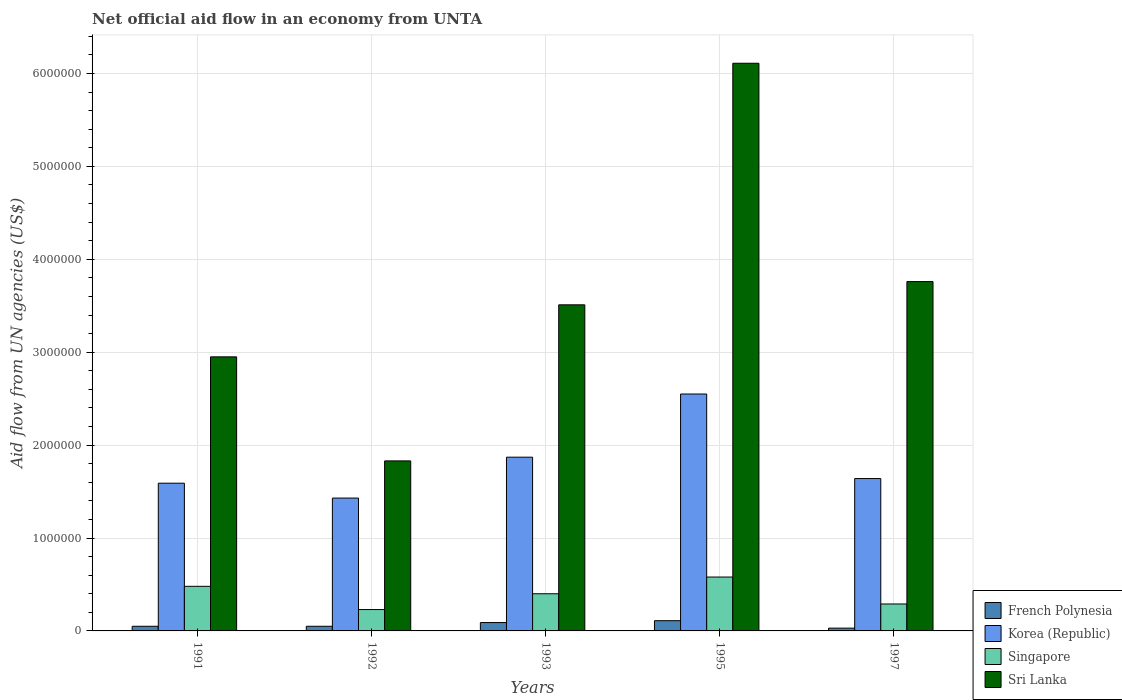How many groups of bars are there?
Provide a short and direct response. 5. Are the number of bars per tick equal to the number of legend labels?
Your answer should be very brief. Yes. What is the label of the 1st group of bars from the left?
Provide a short and direct response. 1991. Across all years, what is the maximum net official aid flow in Korea (Republic)?
Your answer should be compact. 2.55e+06. In which year was the net official aid flow in French Polynesia maximum?
Keep it short and to the point. 1995. What is the total net official aid flow in Sri Lanka in the graph?
Provide a short and direct response. 1.82e+07. What is the difference between the net official aid flow in Korea (Republic) in 1997 and the net official aid flow in French Polynesia in 1995?
Keep it short and to the point. 1.53e+06. What is the average net official aid flow in Sri Lanka per year?
Keep it short and to the point. 3.63e+06. In the year 1993, what is the difference between the net official aid flow in French Polynesia and net official aid flow in Sri Lanka?
Provide a short and direct response. -3.42e+06. In how many years, is the net official aid flow in French Polynesia greater than 2800000 US$?
Your answer should be very brief. 0. What is the ratio of the net official aid flow in Singapore in 1991 to that in 1997?
Ensure brevity in your answer.  1.66. In how many years, is the net official aid flow in Sri Lanka greater than the average net official aid flow in Sri Lanka taken over all years?
Ensure brevity in your answer.  2. Is the sum of the net official aid flow in Singapore in 1991 and 1992 greater than the maximum net official aid flow in French Polynesia across all years?
Offer a very short reply. Yes. Is it the case that in every year, the sum of the net official aid flow in Korea (Republic) and net official aid flow in French Polynesia is greater than the sum of net official aid flow in Singapore and net official aid flow in Sri Lanka?
Keep it short and to the point. No. What does the 4th bar from the left in 1992 represents?
Offer a very short reply. Sri Lanka. What does the 4th bar from the right in 1991 represents?
Keep it short and to the point. French Polynesia. How many bars are there?
Provide a short and direct response. 20. Are all the bars in the graph horizontal?
Provide a succinct answer. No. Are the values on the major ticks of Y-axis written in scientific E-notation?
Offer a terse response. No. How many legend labels are there?
Your response must be concise. 4. How are the legend labels stacked?
Your answer should be compact. Vertical. What is the title of the graph?
Offer a very short reply. Net official aid flow in an economy from UNTA. What is the label or title of the X-axis?
Provide a succinct answer. Years. What is the label or title of the Y-axis?
Give a very brief answer. Aid flow from UN agencies (US$). What is the Aid flow from UN agencies (US$) in French Polynesia in 1991?
Your response must be concise. 5.00e+04. What is the Aid flow from UN agencies (US$) in Korea (Republic) in 1991?
Your answer should be compact. 1.59e+06. What is the Aid flow from UN agencies (US$) of Sri Lanka in 1991?
Provide a short and direct response. 2.95e+06. What is the Aid flow from UN agencies (US$) of Korea (Republic) in 1992?
Make the answer very short. 1.43e+06. What is the Aid flow from UN agencies (US$) in Sri Lanka in 1992?
Your response must be concise. 1.83e+06. What is the Aid flow from UN agencies (US$) in French Polynesia in 1993?
Make the answer very short. 9.00e+04. What is the Aid flow from UN agencies (US$) in Korea (Republic) in 1993?
Offer a terse response. 1.87e+06. What is the Aid flow from UN agencies (US$) in Sri Lanka in 1993?
Make the answer very short. 3.51e+06. What is the Aid flow from UN agencies (US$) in Korea (Republic) in 1995?
Provide a succinct answer. 2.55e+06. What is the Aid flow from UN agencies (US$) in Singapore in 1995?
Your answer should be compact. 5.80e+05. What is the Aid flow from UN agencies (US$) of Sri Lanka in 1995?
Make the answer very short. 6.11e+06. What is the Aid flow from UN agencies (US$) of Korea (Republic) in 1997?
Provide a succinct answer. 1.64e+06. What is the Aid flow from UN agencies (US$) of Singapore in 1997?
Your response must be concise. 2.90e+05. What is the Aid flow from UN agencies (US$) in Sri Lanka in 1997?
Keep it short and to the point. 3.76e+06. Across all years, what is the maximum Aid flow from UN agencies (US$) of Korea (Republic)?
Your answer should be compact. 2.55e+06. Across all years, what is the maximum Aid flow from UN agencies (US$) of Singapore?
Ensure brevity in your answer.  5.80e+05. Across all years, what is the maximum Aid flow from UN agencies (US$) of Sri Lanka?
Your response must be concise. 6.11e+06. Across all years, what is the minimum Aid flow from UN agencies (US$) of Korea (Republic)?
Offer a very short reply. 1.43e+06. Across all years, what is the minimum Aid flow from UN agencies (US$) in Singapore?
Your response must be concise. 2.30e+05. Across all years, what is the minimum Aid flow from UN agencies (US$) of Sri Lanka?
Give a very brief answer. 1.83e+06. What is the total Aid flow from UN agencies (US$) of Korea (Republic) in the graph?
Provide a short and direct response. 9.08e+06. What is the total Aid flow from UN agencies (US$) in Singapore in the graph?
Provide a short and direct response. 1.98e+06. What is the total Aid flow from UN agencies (US$) of Sri Lanka in the graph?
Ensure brevity in your answer.  1.82e+07. What is the difference between the Aid flow from UN agencies (US$) of Sri Lanka in 1991 and that in 1992?
Your answer should be very brief. 1.12e+06. What is the difference between the Aid flow from UN agencies (US$) in French Polynesia in 1991 and that in 1993?
Your response must be concise. -4.00e+04. What is the difference between the Aid flow from UN agencies (US$) in Korea (Republic) in 1991 and that in 1993?
Your answer should be compact. -2.80e+05. What is the difference between the Aid flow from UN agencies (US$) of Sri Lanka in 1991 and that in 1993?
Your answer should be compact. -5.60e+05. What is the difference between the Aid flow from UN agencies (US$) of French Polynesia in 1991 and that in 1995?
Give a very brief answer. -6.00e+04. What is the difference between the Aid flow from UN agencies (US$) of Korea (Republic) in 1991 and that in 1995?
Make the answer very short. -9.60e+05. What is the difference between the Aid flow from UN agencies (US$) in Sri Lanka in 1991 and that in 1995?
Your answer should be compact. -3.16e+06. What is the difference between the Aid flow from UN agencies (US$) of French Polynesia in 1991 and that in 1997?
Your answer should be compact. 2.00e+04. What is the difference between the Aid flow from UN agencies (US$) of Korea (Republic) in 1991 and that in 1997?
Your answer should be very brief. -5.00e+04. What is the difference between the Aid flow from UN agencies (US$) in Singapore in 1991 and that in 1997?
Keep it short and to the point. 1.90e+05. What is the difference between the Aid flow from UN agencies (US$) of Sri Lanka in 1991 and that in 1997?
Provide a succinct answer. -8.10e+05. What is the difference between the Aid flow from UN agencies (US$) in Korea (Republic) in 1992 and that in 1993?
Keep it short and to the point. -4.40e+05. What is the difference between the Aid flow from UN agencies (US$) in Singapore in 1992 and that in 1993?
Your answer should be compact. -1.70e+05. What is the difference between the Aid flow from UN agencies (US$) in Sri Lanka in 1992 and that in 1993?
Ensure brevity in your answer.  -1.68e+06. What is the difference between the Aid flow from UN agencies (US$) of Korea (Republic) in 1992 and that in 1995?
Provide a short and direct response. -1.12e+06. What is the difference between the Aid flow from UN agencies (US$) in Singapore in 1992 and that in 1995?
Your response must be concise. -3.50e+05. What is the difference between the Aid flow from UN agencies (US$) of Sri Lanka in 1992 and that in 1995?
Your answer should be compact. -4.28e+06. What is the difference between the Aid flow from UN agencies (US$) of Korea (Republic) in 1992 and that in 1997?
Offer a very short reply. -2.10e+05. What is the difference between the Aid flow from UN agencies (US$) in Singapore in 1992 and that in 1997?
Your response must be concise. -6.00e+04. What is the difference between the Aid flow from UN agencies (US$) in Sri Lanka in 1992 and that in 1997?
Your answer should be compact. -1.93e+06. What is the difference between the Aid flow from UN agencies (US$) of French Polynesia in 1993 and that in 1995?
Your response must be concise. -2.00e+04. What is the difference between the Aid flow from UN agencies (US$) of Korea (Republic) in 1993 and that in 1995?
Give a very brief answer. -6.80e+05. What is the difference between the Aid flow from UN agencies (US$) in Sri Lanka in 1993 and that in 1995?
Offer a terse response. -2.60e+06. What is the difference between the Aid flow from UN agencies (US$) of French Polynesia in 1995 and that in 1997?
Offer a very short reply. 8.00e+04. What is the difference between the Aid flow from UN agencies (US$) of Korea (Republic) in 1995 and that in 1997?
Ensure brevity in your answer.  9.10e+05. What is the difference between the Aid flow from UN agencies (US$) of Sri Lanka in 1995 and that in 1997?
Make the answer very short. 2.35e+06. What is the difference between the Aid flow from UN agencies (US$) in French Polynesia in 1991 and the Aid flow from UN agencies (US$) in Korea (Republic) in 1992?
Provide a short and direct response. -1.38e+06. What is the difference between the Aid flow from UN agencies (US$) in French Polynesia in 1991 and the Aid flow from UN agencies (US$) in Sri Lanka in 1992?
Give a very brief answer. -1.78e+06. What is the difference between the Aid flow from UN agencies (US$) in Korea (Republic) in 1991 and the Aid flow from UN agencies (US$) in Singapore in 1992?
Your answer should be compact. 1.36e+06. What is the difference between the Aid flow from UN agencies (US$) in Korea (Republic) in 1991 and the Aid flow from UN agencies (US$) in Sri Lanka in 1992?
Provide a short and direct response. -2.40e+05. What is the difference between the Aid flow from UN agencies (US$) in Singapore in 1991 and the Aid flow from UN agencies (US$) in Sri Lanka in 1992?
Give a very brief answer. -1.35e+06. What is the difference between the Aid flow from UN agencies (US$) of French Polynesia in 1991 and the Aid flow from UN agencies (US$) of Korea (Republic) in 1993?
Make the answer very short. -1.82e+06. What is the difference between the Aid flow from UN agencies (US$) of French Polynesia in 1991 and the Aid flow from UN agencies (US$) of Singapore in 1993?
Ensure brevity in your answer.  -3.50e+05. What is the difference between the Aid flow from UN agencies (US$) in French Polynesia in 1991 and the Aid flow from UN agencies (US$) in Sri Lanka in 1993?
Make the answer very short. -3.46e+06. What is the difference between the Aid flow from UN agencies (US$) in Korea (Republic) in 1991 and the Aid flow from UN agencies (US$) in Singapore in 1993?
Provide a short and direct response. 1.19e+06. What is the difference between the Aid flow from UN agencies (US$) in Korea (Republic) in 1991 and the Aid flow from UN agencies (US$) in Sri Lanka in 1993?
Your answer should be very brief. -1.92e+06. What is the difference between the Aid flow from UN agencies (US$) of Singapore in 1991 and the Aid flow from UN agencies (US$) of Sri Lanka in 1993?
Provide a succinct answer. -3.03e+06. What is the difference between the Aid flow from UN agencies (US$) of French Polynesia in 1991 and the Aid flow from UN agencies (US$) of Korea (Republic) in 1995?
Give a very brief answer. -2.50e+06. What is the difference between the Aid flow from UN agencies (US$) in French Polynesia in 1991 and the Aid flow from UN agencies (US$) in Singapore in 1995?
Provide a succinct answer. -5.30e+05. What is the difference between the Aid flow from UN agencies (US$) in French Polynesia in 1991 and the Aid flow from UN agencies (US$) in Sri Lanka in 1995?
Ensure brevity in your answer.  -6.06e+06. What is the difference between the Aid flow from UN agencies (US$) in Korea (Republic) in 1991 and the Aid flow from UN agencies (US$) in Singapore in 1995?
Your answer should be compact. 1.01e+06. What is the difference between the Aid flow from UN agencies (US$) of Korea (Republic) in 1991 and the Aid flow from UN agencies (US$) of Sri Lanka in 1995?
Your response must be concise. -4.52e+06. What is the difference between the Aid flow from UN agencies (US$) of Singapore in 1991 and the Aid flow from UN agencies (US$) of Sri Lanka in 1995?
Keep it short and to the point. -5.63e+06. What is the difference between the Aid flow from UN agencies (US$) of French Polynesia in 1991 and the Aid flow from UN agencies (US$) of Korea (Republic) in 1997?
Your answer should be compact. -1.59e+06. What is the difference between the Aid flow from UN agencies (US$) in French Polynesia in 1991 and the Aid flow from UN agencies (US$) in Singapore in 1997?
Offer a terse response. -2.40e+05. What is the difference between the Aid flow from UN agencies (US$) in French Polynesia in 1991 and the Aid flow from UN agencies (US$) in Sri Lanka in 1997?
Your answer should be compact. -3.71e+06. What is the difference between the Aid flow from UN agencies (US$) of Korea (Republic) in 1991 and the Aid flow from UN agencies (US$) of Singapore in 1997?
Ensure brevity in your answer.  1.30e+06. What is the difference between the Aid flow from UN agencies (US$) in Korea (Republic) in 1991 and the Aid flow from UN agencies (US$) in Sri Lanka in 1997?
Offer a very short reply. -2.17e+06. What is the difference between the Aid flow from UN agencies (US$) of Singapore in 1991 and the Aid flow from UN agencies (US$) of Sri Lanka in 1997?
Your answer should be compact. -3.28e+06. What is the difference between the Aid flow from UN agencies (US$) of French Polynesia in 1992 and the Aid flow from UN agencies (US$) of Korea (Republic) in 1993?
Provide a short and direct response. -1.82e+06. What is the difference between the Aid flow from UN agencies (US$) in French Polynesia in 1992 and the Aid flow from UN agencies (US$) in Singapore in 1993?
Keep it short and to the point. -3.50e+05. What is the difference between the Aid flow from UN agencies (US$) in French Polynesia in 1992 and the Aid flow from UN agencies (US$) in Sri Lanka in 1993?
Your response must be concise. -3.46e+06. What is the difference between the Aid flow from UN agencies (US$) in Korea (Republic) in 1992 and the Aid flow from UN agencies (US$) in Singapore in 1993?
Offer a very short reply. 1.03e+06. What is the difference between the Aid flow from UN agencies (US$) in Korea (Republic) in 1992 and the Aid flow from UN agencies (US$) in Sri Lanka in 1993?
Offer a very short reply. -2.08e+06. What is the difference between the Aid flow from UN agencies (US$) of Singapore in 1992 and the Aid flow from UN agencies (US$) of Sri Lanka in 1993?
Ensure brevity in your answer.  -3.28e+06. What is the difference between the Aid flow from UN agencies (US$) in French Polynesia in 1992 and the Aid flow from UN agencies (US$) in Korea (Republic) in 1995?
Your answer should be very brief. -2.50e+06. What is the difference between the Aid flow from UN agencies (US$) in French Polynesia in 1992 and the Aid flow from UN agencies (US$) in Singapore in 1995?
Offer a very short reply. -5.30e+05. What is the difference between the Aid flow from UN agencies (US$) in French Polynesia in 1992 and the Aid flow from UN agencies (US$) in Sri Lanka in 1995?
Your answer should be compact. -6.06e+06. What is the difference between the Aid flow from UN agencies (US$) in Korea (Republic) in 1992 and the Aid flow from UN agencies (US$) in Singapore in 1995?
Offer a terse response. 8.50e+05. What is the difference between the Aid flow from UN agencies (US$) of Korea (Republic) in 1992 and the Aid flow from UN agencies (US$) of Sri Lanka in 1995?
Make the answer very short. -4.68e+06. What is the difference between the Aid flow from UN agencies (US$) in Singapore in 1992 and the Aid flow from UN agencies (US$) in Sri Lanka in 1995?
Your answer should be very brief. -5.88e+06. What is the difference between the Aid flow from UN agencies (US$) in French Polynesia in 1992 and the Aid flow from UN agencies (US$) in Korea (Republic) in 1997?
Offer a terse response. -1.59e+06. What is the difference between the Aid flow from UN agencies (US$) in French Polynesia in 1992 and the Aid flow from UN agencies (US$) in Sri Lanka in 1997?
Ensure brevity in your answer.  -3.71e+06. What is the difference between the Aid flow from UN agencies (US$) in Korea (Republic) in 1992 and the Aid flow from UN agencies (US$) in Singapore in 1997?
Keep it short and to the point. 1.14e+06. What is the difference between the Aid flow from UN agencies (US$) in Korea (Republic) in 1992 and the Aid flow from UN agencies (US$) in Sri Lanka in 1997?
Provide a short and direct response. -2.33e+06. What is the difference between the Aid flow from UN agencies (US$) of Singapore in 1992 and the Aid flow from UN agencies (US$) of Sri Lanka in 1997?
Make the answer very short. -3.53e+06. What is the difference between the Aid flow from UN agencies (US$) in French Polynesia in 1993 and the Aid flow from UN agencies (US$) in Korea (Republic) in 1995?
Your answer should be very brief. -2.46e+06. What is the difference between the Aid flow from UN agencies (US$) in French Polynesia in 1993 and the Aid flow from UN agencies (US$) in Singapore in 1995?
Give a very brief answer. -4.90e+05. What is the difference between the Aid flow from UN agencies (US$) in French Polynesia in 1993 and the Aid flow from UN agencies (US$) in Sri Lanka in 1995?
Ensure brevity in your answer.  -6.02e+06. What is the difference between the Aid flow from UN agencies (US$) in Korea (Republic) in 1993 and the Aid flow from UN agencies (US$) in Singapore in 1995?
Provide a succinct answer. 1.29e+06. What is the difference between the Aid flow from UN agencies (US$) in Korea (Republic) in 1993 and the Aid flow from UN agencies (US$) in Sri Lanka in 1995?
Make the answer very short. -4.24e+06. What is the difference between the Aid flow from UN agencies (US$) in Singapore in 1993 and the Aid flow from UN agencies (US$) in Sri Lanka in 1995?
Offer a very short reply. -5.71e+06. What is the difference between the Aid flow from UN agencies (US$) in French Polynesia in 1993 and the Aid flow from UN agencies (US$) in Korea (Republic) in 1997?
Give a very brief answer. -1.55e+06. What is the difference between the Aid flow from UN agencies (US$) of French Polynesia in 1993 and the Aid flow from UN agencies (US$) of Singapore in 1997?
Give a very brief answer. -2.00e+05. What is the difference between the Aid flow from UN agencies (US$) in French Polynesia in 1993 and the Aid flow from UN agencies (US$) in Sri Lanka in 1997?
Provide a short and direct response. -3.67e+06. What is the difference between the Aid flow from UN agencies (US$) in Korea (Republic) in 1993 and the Aid flow from UN agencies (US$) in Singapore in 1997?
Your answer should be very brief. 1.58e+06. What is the difference between the Aid flow from UN agencies (US$) in Korea (Republic) in 1993 and the Aid flow from UN agencies (US$) in Sri Lanka in 1997?
Give a very brief answer. -1.89e+06. What is the difference between the Aid flow from UN agencies (US$) of Singapore in 1993 and the Aid flow from UN agencies (US$) of Sri Lanka in 1997?
Provide a short and direct response. -3.36e+06. What is the difference between the Aid flow from UN agencies (US$) of French Polynesia in 1995 and the Aid flow from UN agencies (US$) of Korea (Republic) in 1997?
Provide a short and direct response. -1.53e+06. What is the difference between the Aid flow from UN agencies (US$) of French Polynesia in 1995 and the Aid flow from UN agencies (US$) of Sri Lanka in 1997?
Offer a terse response. -3.65e+06. What is the difference between the Aid flow from UN agencies (US$) of Korea (Republic) in 1995 and the Aid flow from UN agencies (US$) of Singapore in 1997?
Give a very brief answer. 2.26e+06. What is the difference between the Aid flow from UN agencies (US$) of Korea (Republic) in 1995 and the Aid flow from UN agencies (US$) of Sri Lanka in 1997?
Ensure brevity in your answer.  -1.21e+06. What is the difference between the Aid flow from UN agencies (US$) of Singapore in 1995 and the Aid flow from UN agencies (US$) of Sri Lanka in 1997?
Offer a very short reply. -3.18e+06. What is the average Aid flow from UN agencies (US$) of French Polynesia per year?
Make the answer very short. 6.60e+04. What is the average Aid flow from UN agencies (US$) in Korea (Republic) per year?
Provide a succinct answer. 1.82e+06. What is the average Aid flow from UN agencies (US$) in Singapore per year?
Your response must be concise. 3.96e+05. What is the average Aid flow from UN agencies (US$) of Sri Lanka per year?
Provide a succinct answer. 3.63e+06. In the year 1991, what is the difference between the Aid flow from UN agencies (US$) in French Polynesia and Aid flow from UN agencies (US$) in Korea (Republic)?
Make the answer very short. -1.54e+06. In the year 1991, what is the difference between the Aid flow from UN agencies (US$) of French Polynesia and Aid flow from UN agencies (US$) of Singapore?
Your response must be concise. -4.30e+05. In the year 1991, what is the difference between the Aid flow from UN agencies (US$) in French Polynesia and Aid flow from UN agencies (US$) in Sri Lanka?
Ensure brevity in your answer.  -2.90e+06. In the year 1991, what is the difference between the Aid flow from UN agencies (US$) in Korea (Republic) and Aid flow from UN agencies (US$) in Singapore?
Offer a very short reply. 1.11e+06. In the year 1991, what is the difference between the Aid flow from UN agencies (US$) of Korea (Republic) and Aid flow from UN agencies (US$) of Sri Lanka?
Your answer should be compact. -1.36e+06. In the year 1991, what is the difference between the Aid flow from UN agencies (US$) of Singapore and Aid flow from UN agencies (US$) of Sri Lanka?
Give a very brief answer. -2.47e+06. In the year 1992, what is the difference between the Aid flow from UN agencies (US$) of French Polynesia and Aid flow from UN agencies (US$) of Korea (Republic)?
Your response must be concise. -1.38e+06. In the year 1992, what is the difference between the Aid flow from UN agencies (US$) in French Polynesia and Aid flow from UN agencies (US$) in Singapore?
Provide a succinct answer. -1.80e+05. In the year 1992, what is the difference between the Aid flow from UN agencies (US$) in French Polynesia and Aid flow from UN agencies (US$) in Sri Lanka?
Provide a short and direct response. -1.78e+06. In the year 1992, what is the difference between the Aid flow from UN agencies (US$) of Korea (Republic) and Aid flow from UN agencies (US$) of Singapore?
Offer a very short reply. 1.20e+06. In the year 1992, what is the difference between the Aid flow from UN agencies (US$) of Korea (Republic) and Aid flow from UN agencies (US$) of Sri Lanka?
Ensure brevity in your answer.  -4.00e+05. In the year 1992, what is the difference between the Aid flow from UN agencies (US$) of Singapore and Aid flow from UN agencies (US$) of Sri Lanka?
Give a very brief answer. -1.60e+06. In the year 1993, what is the difference between the Aid flow from UN agencies (US$) of French Polynesia and Aid flow from UN agencies (US$) of Korea (Republic)?
Make the answer very short. -1.78e+06. In the year 1993, what is the difference between the Aid flow from UN agencies (US$) in French Polynesia and Aid flow from UN agencies (US$) in Singapore?
Provide a short and direct response. -3.10e+05. In the year 1993, what is the difference between the Aid flow from UN agencies (US$) in French Polynesia and Aid flow from UN agencies (US$) in Sri Lanka?
Your answer should be compact. -3.42e+06. In the year 1993, what is the difference between the Aid flow from UN agencies (US$) in Korea (Republic) and Aid flow from UN agencies (US$) in Singapore?
Provide a succinct answer. 1.47e+06. In the year 1993, what is the difference between the Aid flow from UN agencies (US$) in Korea (Republic) and Aid flow from UN agencies (US$) in Sri Lanka?
Keep it short and to the point. -1.64e+06. In the year 1993, what is the difference between the Aid flow from UN agencies (US$) in Singapore and Aid flow from UN agencies (US$) in Sri Lanka?
Give a very brief answer. -3.11e+06. In the year 1995, what is the difference between the Aid flow from UN agencies (US$) of French Polynesia and Aid flow from UN agencies (US$) of Korea (Republic)?
Ensure brevity in your answer.  -2.44e+06. In the year 1995, what is the difference between the Aid flow from UN agencies (US$) in French Polynesia and Aid flow from UN agencies (US$) in Singapore?
Your response must be concise. -4.70e+05. In the year 1995, what is the difference between the Aid flow from UN agencies (US$) in French Polynesia and Aid flow from UN agencies (US$) in Sri Lanka?
Ensure brevity in your answer.  -6.00e+06. In the year 1995, what is the difference between the Aid flow from UN agencies (US$) in Korea (Republic) and Aid flow from UN agencies (US$) in Singapore?
Your answer should be very brief. 1.97e+06. In the year 1995, what is the difference between the Aid flow from UN agencies (US$) in Korea (Republic) and Aid flow from UN agencies (US$) in Sri Lanka?
Keep it short and to the point. -3.56e+06. In the year 1995, what is the difference between the Aid flow from UN agencies (US$) in Singapore and Aid flow from UN agencies (US$) in Sri Lanka?
Make the answer very short. -5.53e+06. In the year 1997, what is the difference between the Aid flow from UN agencies (US$) in French Polynesia and Aid flow from UN agencies (US$) in Korea (Republic)?
Your response must be concise. -1.61e+06. In the year 1997, what is the difference between the Aid flow from UN agencies (US$) in French Polynesia and Aid flow from UN agencies (US$) in Sri Lanka?
Your answer should be very brief. -3.73e+06. In the year 1997, what is the difference between the Aid flow from UN agencies (US$) of Korea (Republic) and Aid flow from UN agencies (US$) of Singapore?
Your answer should be compact. 1.35e+06. In the year 1997, what is the difference between the Aid flow from UN agencies (US$) in Korea (Republic) and Aid flow from UN agencies (US$) in Sri Lanka?
Offer a very short reply. -2.12e+06. In the year 1997, what is the difference between the Aid flow from UN agencies (US$) in Singapore and Aid flow from UN agencies (US$) in Sri Lanka?
Give a very brief answer. -3.47e+06. What is the ratio of the Aid flow from UN agencies (US$) of French Polynesia in 1991 to that in 1992?
Make the answer very short. 1. What is the ratio of the Aid flow from UN agencies (US$) in Korea (Republic) in 1991 to that in 1992?
Ensure brevity in your answer.  1.11. What is the ratio of the Aid flow from UN agencies (US$) of Singapore in 1991 to that in 1992?
Give a very brief answer. 2.09. What is the ratio of the Aid flow from UN agencies (US$) in Sri Lanka in 1991 to that in 1992?
Offer a terse response. 1.61. What is the ratio of the Aid flow from UN agencies (US$) of French Polynesia in 1991 to that in 1993?
Make the answer very short. 0.56. What is the ratio of the Aid flow from UN agencies (US$) of Korea (Republic) in 1991 to that in 1993?
Your response must be concise. 0.85. What is the ratio of the Aid flow from UN agencies (US$) of Singapore in 1991 to that in 1993?
Ensure brevity in your answer.  1.2. What is the ratio of the Aid flow from UN agencies (US$) of Sri Lanka in 1991 to that in 1993?
Make the answer very short. 0.84. What is the ratio of the Aid flow from UN agencies (US$) in French Polynesia in 1991 to that in 1995?
Make the answer very short. 0.45. What is the ratio of the Aid flow from UN agencies (US$) of Korea (Republic) in 1991 to that in 1995?
Offer a terse response. 0.62. What is the ratio of the Aid flow from UN agencies (US$) of Singapore in 1991 to that in 1995?
Provide a short and direct response. 0.83. What is the ratio of the Aid flow from UN agencies (US$) in Sri Lanka in 1991 to that in 1995?
Offer a very short reply. 0.48. What is the ratio of the Aid flow from UN agencies (US$) of Korea (Republic) in 1991 to that in 1997?
Your answer should be very brief. 0.97. What is the ratio of the Aid flow from UN agencies (US$) of Singapore in 1991 to that in 1997?
Your response must be concise. 1.66. What is the ratio of the Aid flow from UN agencies (US$) in Sri Lanka in 1991 to that in 1997?
Your answer should be very brief. 0.78. What is the ratio of the Aid flow from UN agencies (US$) of French Polynesia in 1992 to that in 1993?
Provide a succinct answer. 0.56. What is the ratio of the Aid flow from UN agencies (US$) of Korea (Republic) in 1992 to that in 1993?
Ensure brevity in your answer.  0.76. What is the ratio of the Aid flow from UN agencies (US$) in Singapore in 1992 to that in 1993?
Provide a succinct answer. 0.57. What is the ratio of the Aid flow from UN agencies (US$) in Sri Lanka in 1992 to that in 1993?
Ensure brevity in your answer.  0.52. What is the ratio of the Aid flow from UN agencies (US$) in French Polynesia in 1992 to that in 1995?
Your answer should be very brief. 0.45. What is the ratio of the Aid flow from UN agencies (US$) of Korea (Republic) in 1992 to that in 1995?
Provide a succinct answer. 0.56. What is the ratio of the Aid flow from UN agencies (US$) in Singapore in 1992 to that in 1995?
Provide a succinct answer. 0.4. What is the ratio of the Aid flow from UN agencies (US$) of Sri Lanka in 1992 to that in 1995?
Provide a succinct answer. 0.3. What is the ratio of the Aid flow from UN agencies (US$) in Korea (Republic) in 1992 to that in 1997?
Offer a very short reply. 0.87. What is the ratio of the Aid flow from UN agencies (US$) of Singapore in 1992 to that in 1997?
Provide a succinct answer. 0.79. What is the ratio of the Aid flow from UN agencies (US$) in Sri Lanka in 1992 to that in 1997?
Keep it short and to the point. 0.49. What is the ratio of the Aid flow from UN agencies (US$) in French Polynesia in 1993 to that in 1995?
Your response must be concise. 0.82. What is the ratio of the Aid flow from UN agencies (US$) of Korea (Republic) in 1993 to that in 1995?
Ensure brevity in your answer.  0.73. What is the ratio of the Aid flow from UN agencies (US$) of Singapore in 1993 to that in 1995?
Offer a terse response. 0.69. What is the ratio of the Aid flow from UN agencies (US$) of Sri Lanka in 1993 to that in 1995?
Provide a short and direct response. 0.57. What is the ratio of the Aid flow from UN agencies (US$) of French Polynesia in 1993 to that in 1997?
Your answer should be compact. 3. What is the ratio of the Aid flow from UN agencies (US$) in Korea (Republic) in 1993 to that in 1997?
Make the answer very short. 1.14. What is the ratio of the Aid flow from UN agencies (US$) in Singapore in 1993 to that in 1997?
Offer a very short reply. 1.38. What is the ratio of the Aid flow from UN agencies (US$) of Sri Lanka in 1993 to that in 1997?
Make the answer very short. 0.93. What is the ratio of the Aid flow from UN agencies (US$) of French Polynesia in 1995 to that in 1997?
Your answer should be compact. 3.67. What is the ratio of the Aid flow from UN agencies (US$) in Korea (Republic) in 1995 to that in 1997?
Your answer should be very brief. 1.55. What is the ratio of the Aid flow from UN agencies (US$) in Sri Lanka in 1995 to that in 1997?
Make the answer very short. 1.62. What is the difference between the highest and the second highest Aid flow from UN agencies (US$) in Korea (Republic)?
Ensure brevity in your answer.  6.80e+05. What is the difference between the highest and the second highest Aid flow from UN agencies (US$) of Singapore?
Provide a short and direct response. 1.00e+05. What is the difference between the highest and the second highest Aid flow from UN agencies (US$) in Sri Lanka?
Your answer should be compact. 2.35e+06. What is the difference between the highest and the lowest Aid flow from UN agencies (US$) of French Polynesia?
Your answer should be very brief. 8.00e+04. What is the difference between the highest and the lowest Aid flow from UN agencies (US$) in Korea (Republic)?
Your answer should be very brief. 1.12e+06. What is the difference between the highest and the lowest Aid flow from UN agencies (US$) of Sri Lanka?
Keep it short and to the point. 4.28e+06. 